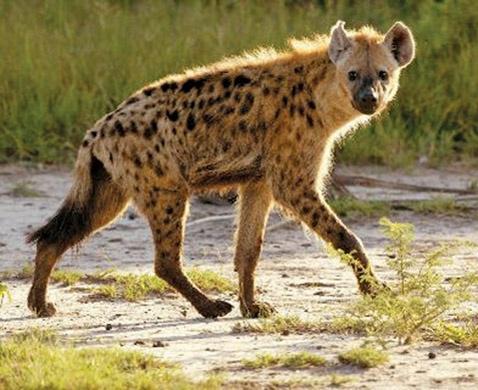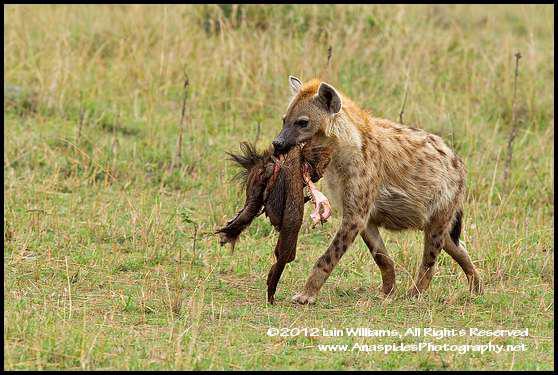The first image is the image on the left, the second image is the image on the right. Assess this claim about the two images: "There is a hyena carrying prey in its mouth.". Correct or not? Answer yes or no. Yes. The first image is the image on the left, the second image is the image on the right. Given the left and right images, does the statement "There is at least one animal carrying another animal or part of another animal." hold true? Answer yes or no. Yes. 